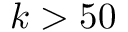Convert formula to latex. <formula><loc_0><loc_0><loc_500><loc_500>k > 5 0</formula> 